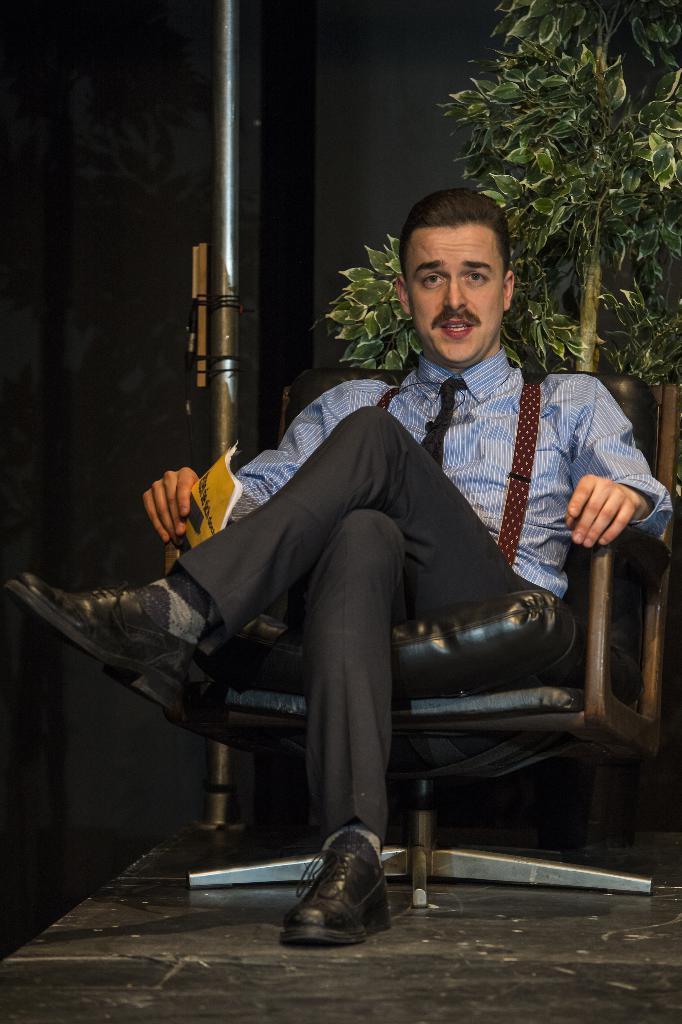Can you describe this image briefly? In this image there is a who is sitting on a chair and he is holding a book. Behind him there is a plant. And on the right side there is a black wall. 